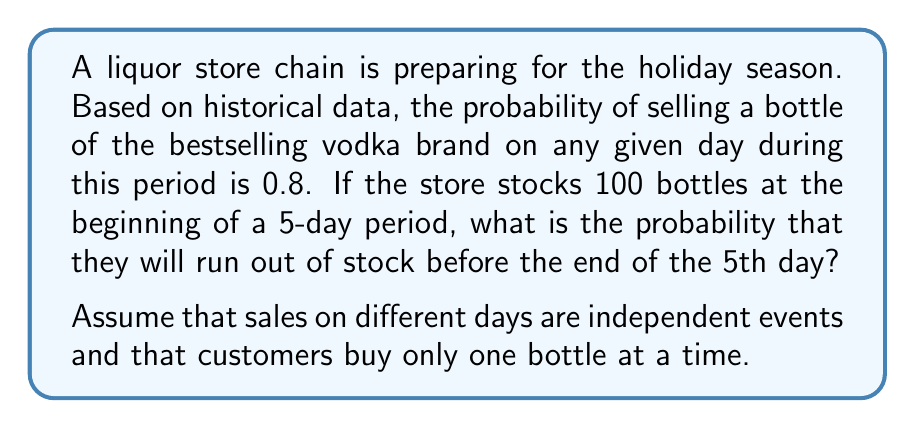Provide a solution to this math problem. Let's approach this step-by-step:

1) First, we need to calculate the probability of not running out of stock. This is equivalent to selling 100 or fewer bottles over the 5-day period.

2) The number of bottles sold follows a binomial distribution with parameters:
   $n = 5$ (number of days)
   $p = 0.8$ (probability of selling a bottle on a given day)
   $N = 100$ (number of trials, i.e., bottles)

3) We can use the cumulative binomial probability function to calculate the probability of selling 100 or fewer bottles:

   $$P(X \leq 100) = \sum_{k=0}^{100} \binom{5N}{k} p^k (1-p)^{5N-k}$$

   where $X$ is the number of bottles sold.

4) However, this calculation is computationally intensive. Instead, we can use the normal approximation to the binomial distribution when $np$ and $n(1-p)$ are both greater than 5, which is the case here.

5) The mean of this distribution is:
   $$\mu = 5Np = 5 \cdot 100 \cdot 0.8 = 400$$

6) The standard deviation is:
   $$\sigma = \sqrt{5Np(1-p)} = \sqrt{5 \cdot 100 \cdot 0.8 \cdot 0.2} = \sqrt{80} \approx 8.94$$

7) We can now use the standard normal distribution to approximate:

   $$P(X \leq 100) \approx P(Z \leq \frac{100.5 - 400}{8.94}) = P(Z \leq -33.45)$$

   Note: We use 100.5 instead of 100 for continuity correction.

8) The probability of $Z \leq -33.45$ is essentially 0.

9) Therefore, the probability of running out of stock is:

   $$P(\text{running out}) = 1 - P(X \leq 100) \approx 1 - 0 = 1$$
Answer: The probability of running out of stock before the end of the 5th day is approximately 1 or 100%. 